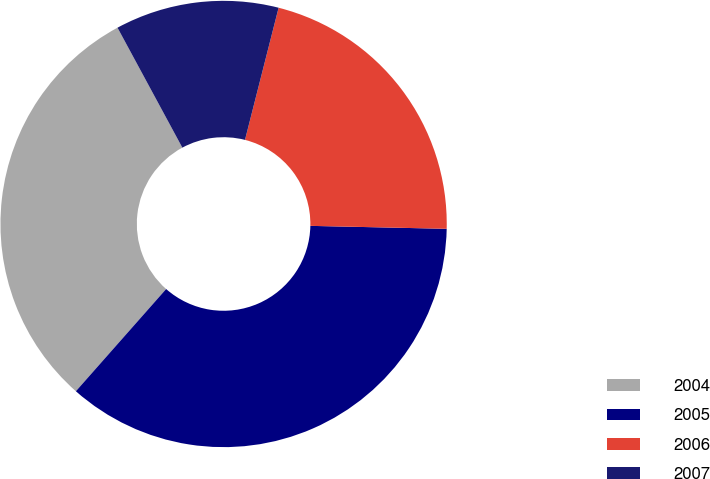Convert chart. <chart><loc_0><loc_0><loc_500><loc_500><pie_chart><fcel>2004<fcel>2005<fcel>2006<fcel>2007<nl><fcel>30.6%<fcel>36.17%<fcel>21.38%<fcel>11.85%<nl></chart> 